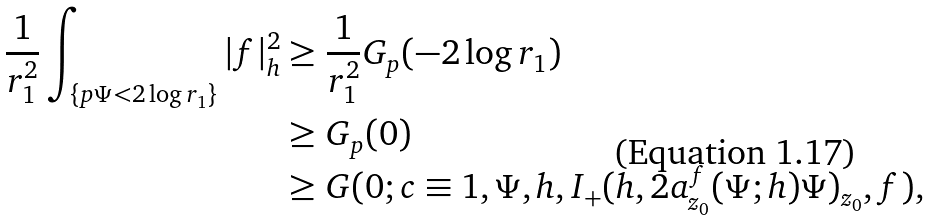<formula> <loc_0><loc_0><loc_500><loc_500>\frac { 1 } { r _ { 1 } ^ { 2 } } \int _ { \{ p \Psi < 2 \log r _ { 1 } \} } | f | ^ { 2 } _ { h } & \geq \frac { 1 } { r _ { 1 } ^ { 2 } } G _ { p } ( - 2 \log r _ { 1 } ) \\ & \geq G _ { p } ( 0 ) \\ & \geq G ( 0 ; c \equiv 1 , \Psi , h , I _ { + } ( h , 2 a _ { z _ { 0 } } ^ { f } ( \Psi ; h ) \Psi ) _ { z _ { 0 } } , f ) ,</formula> 